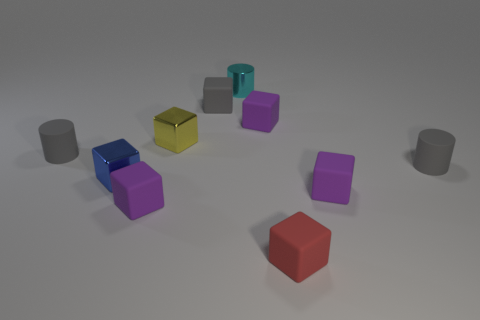What could the collection of shapes represent or be used for? The collection of shapes might represent a set for educational purposes, used for teaching geometry, sorting activities, or as a visual aid for discussing properties of different solids. Could this be part of a child's playset? Absolutely, these shapes could very well be part of a child's playset, perhaps blocks for constructing or for cognitive development activities, like understanding colors and shapes. Which shape would be the most stable to build with? The most stable shape to build with would likely be the cubes, as their equal sides and flat surfaces make them great for stacking and constructing stable structures. 